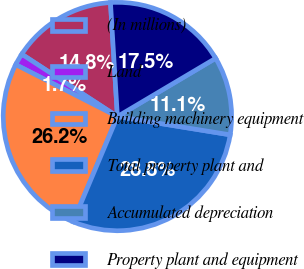Convert chart to OTSL. <chart><loc_0><loc_0><loc_500><loc_500><pie_chart><fcel>(In millions)<fcel>Land<fcel>Building machinery equipment<fcel>Total property plant and<fcel>Accumulated depreciation<fcel>Property plant and equipment<nl><fcel>14.84%<fcel>1.68%<fcel>26.17%<fcel>28.78%<fcel>11.08%<fcel>17.45%<nl></chart> 